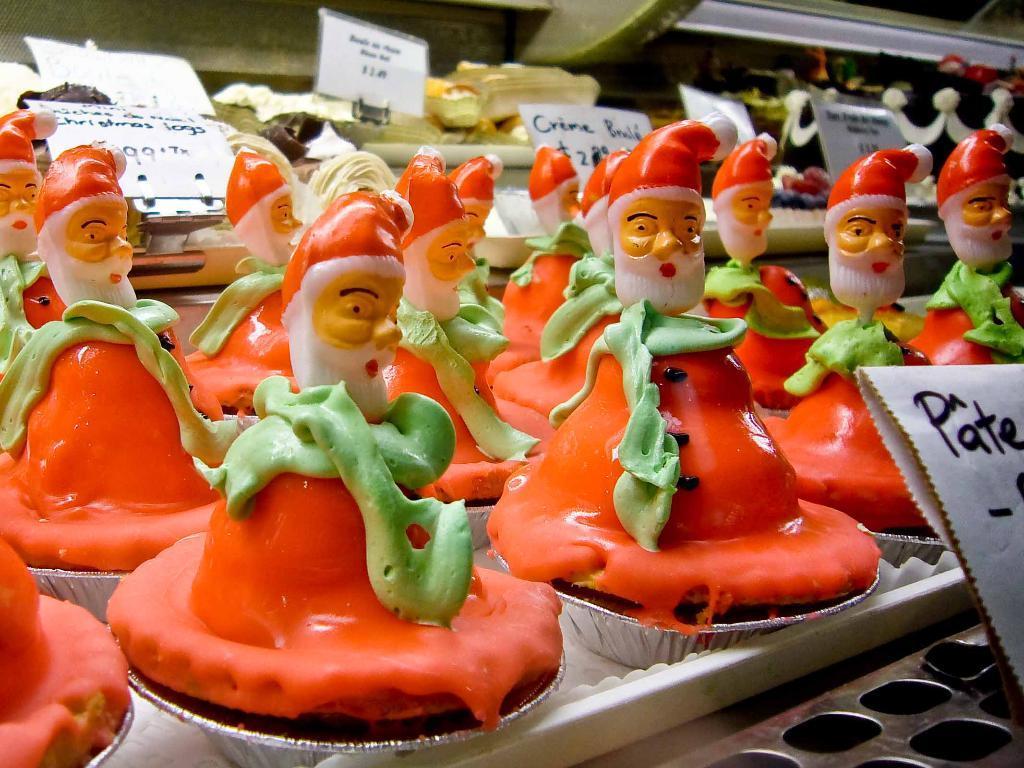How would you summarize this image in a sentence or two? In this image I can see few silver colored bowls on white colored trays and on the bowls I can see few food items which are green, orange, white and cream in color. I can see few white colored boards and few words written on them. In the background I can see few other objects. 